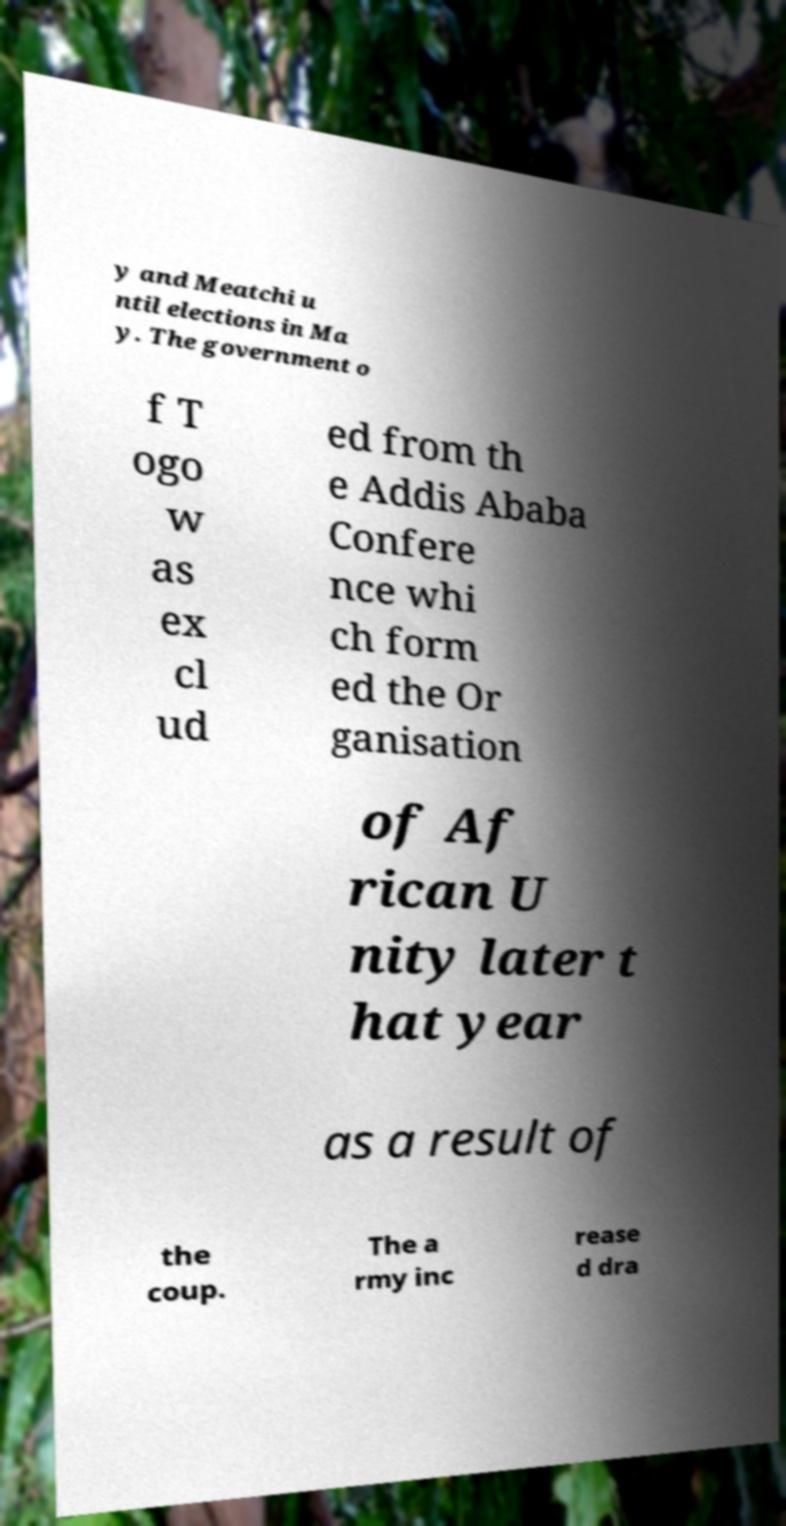What messages or text are displayed in this image? I need them in a readable, typed format. y and Meatchi u ntil elections in Ma y. The government o f T ogo w as ex cl ud ed from th e Addis Ababa Confere nce whi ch form ed the Or ganisation of Af rican U nity later t hat year as a result of the coup. The a rmy inc rease d dra 